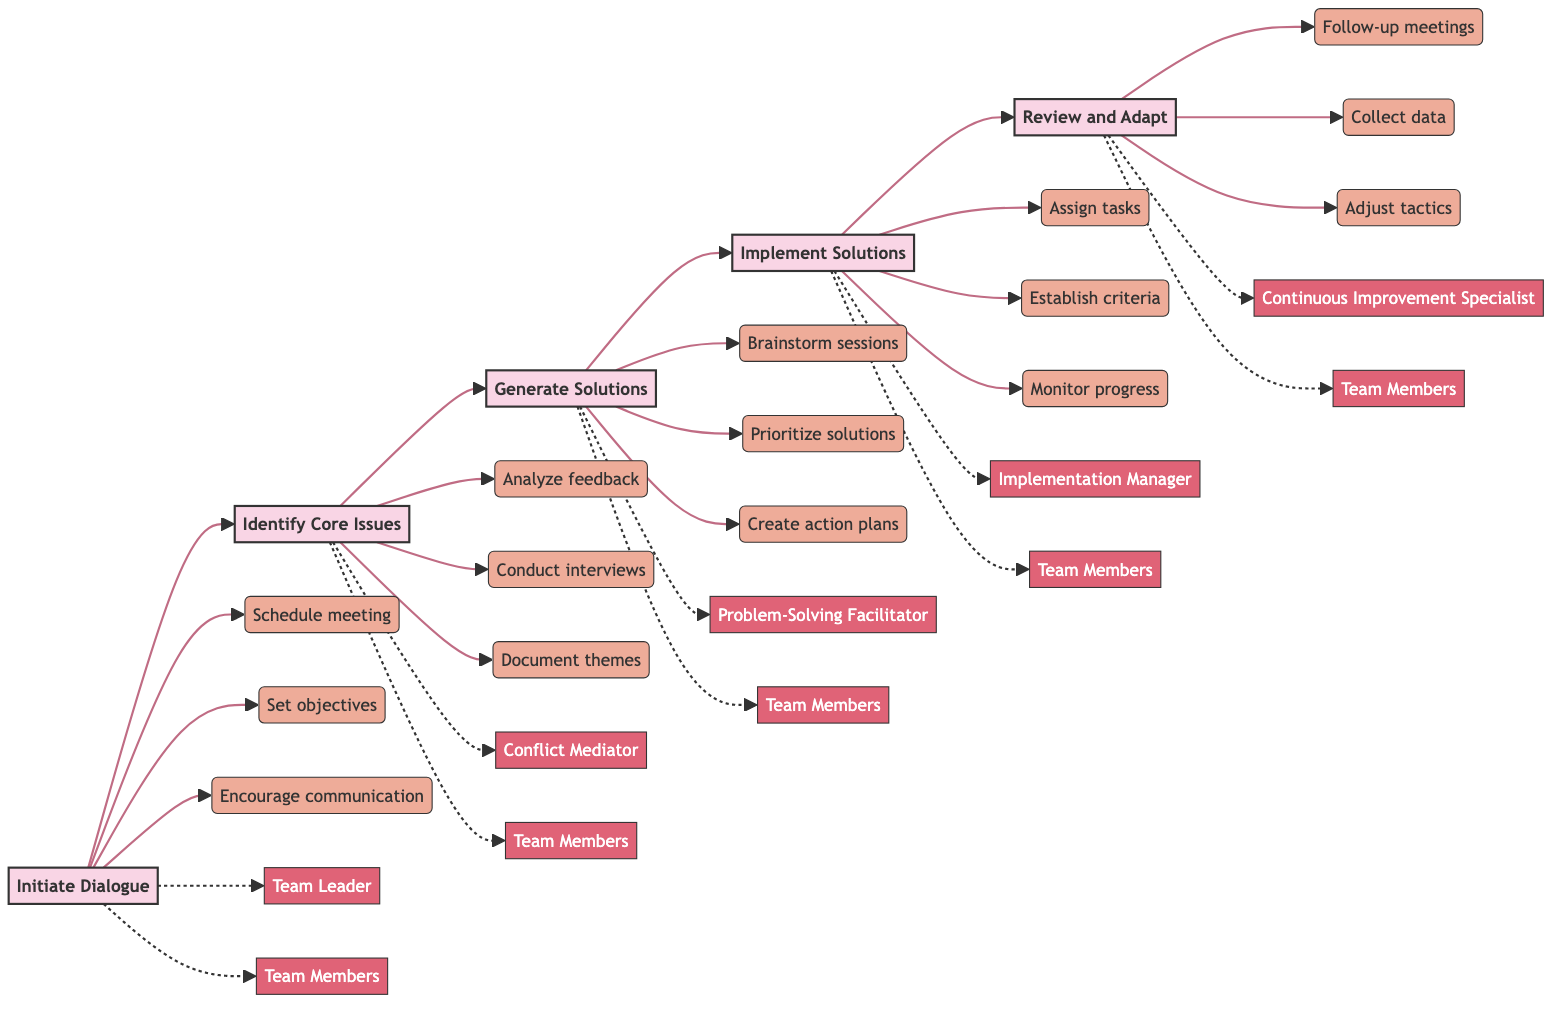What is the first step in the conflict resolution process? The first step, as indicated in the diagram, is "Initiate Dialogue." It is positioned at the beginning of the flowchart, signaling the start of the conflict resolution process.
Answer: Initiate Dialogue Who are the key personnel involved in generating solutions? The diagram shows that the key personnel for generating solutions are "Problem-Solving Facilitator" and "Team Members," marked alongside the corresponding step in the flowchart.
Answer: Problem-Solving Facilitator, Team Members What action is associated with the "Review and Adapt" step? In the diagram, the actions associated with the "Review and Adapt" step include "Conduct follow-up meetings," "Collect performance data," and "Adjust tactics," as depicted below that step in the flowchart.
Answer: Conduct follow-up meetings, Collect performance data, Adjust tactics How many steps are there in the systematic approach? The diagram illustrates a total of five steps represented in the horizontal flowchart, which are sequentially connected from "Initiate Dialogue" to "Review and Adapt."
Answer: Five Which step follows "Implement Solutions"? According to the flowchart, the step that follows "Implement Solutions" is "Review and Adapt," indicating the next phase in the process after solutions have been applied.
Answer: Review and Adapt What is the relationship between "Identify Core Issues" and "Generate Solutions"? The diagram demonstrates a sequential relationship between these two steps, where "Identify Core Issues" directly leads to "Generate Solutions," indicating that addressing the core issues is essential before developing solutions.
Answer: Sequential relationship What is the last action listed in the diagram? The last action shown in the flowchart is "Adjust tactics," which is part of the final step, "Review and Adapt," indicating an ongoing process of improvement.
Answer: Adjust tactics Which key personnel are involved in implementing solutions? The key personnel responsible for implementing solutions, as outlined in the flowchart, are "Implementation Manager" and "Team Members." This dual involvement emphasizes collaboration during this phase.
Answer: Implementation Manager, Team Members What is the main purpose of the "Generate Solutions" step? The main purpose highlighted in the diagram for the "Generate Solutions" step is to develop practical and innovative resolutions, aimed at effectively addressing the identified core issues.
Answer: Develop practical and innovative resolutions 